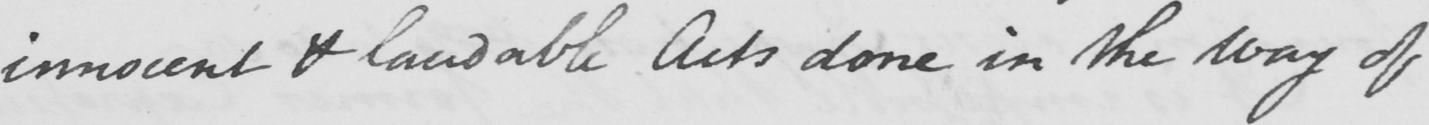Please provide the text content of this handwritten line. innocent & laudable Acts done in the way of 